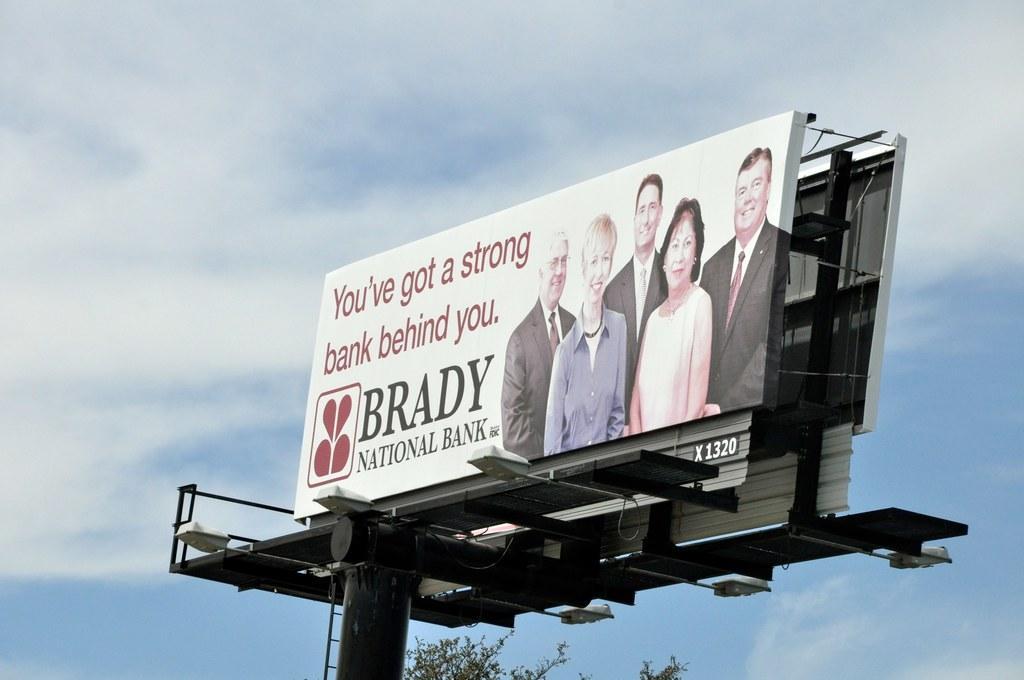Describe this image in one or two sentences. There is a pole with a stand. On that there are lights and ladder. Also there is a banner. On that there are some persons standing and something is written on that. In the background there is sky and a part of a tree is visible. 